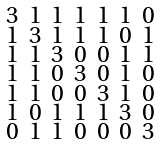<formula> <loc_0><loc_0><loc_500><loc_500>\begin{smallmatrix} 3 & 1 & 1 & 1 & 1 & 1 & 0 \\ 1 & 3 & 1 & 1 & 1 & 0 & 1 \\ 1 & 1 & 3 & 0 & 0 & 1 & 1 \\ 1 & 1 & 0 & 3 & 0 & 1 & 0 \\ 1 & 1 & 0 & 0 & 3 & 1 & 0 \\ 1 & 0 & 1 & 1 & 1 & 3 & 0 \\ 0 & 1 & 1 & 0 & 0 & 0 & 3 \end{smallmatrix}</formula> 